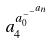<formula> <loc_0><loc_0><loc_500><loc_500>a _ { 4 } ^ { a _ { 0 } ^ { - ^ { - ^ { a _ { n } } } } }</formula> 